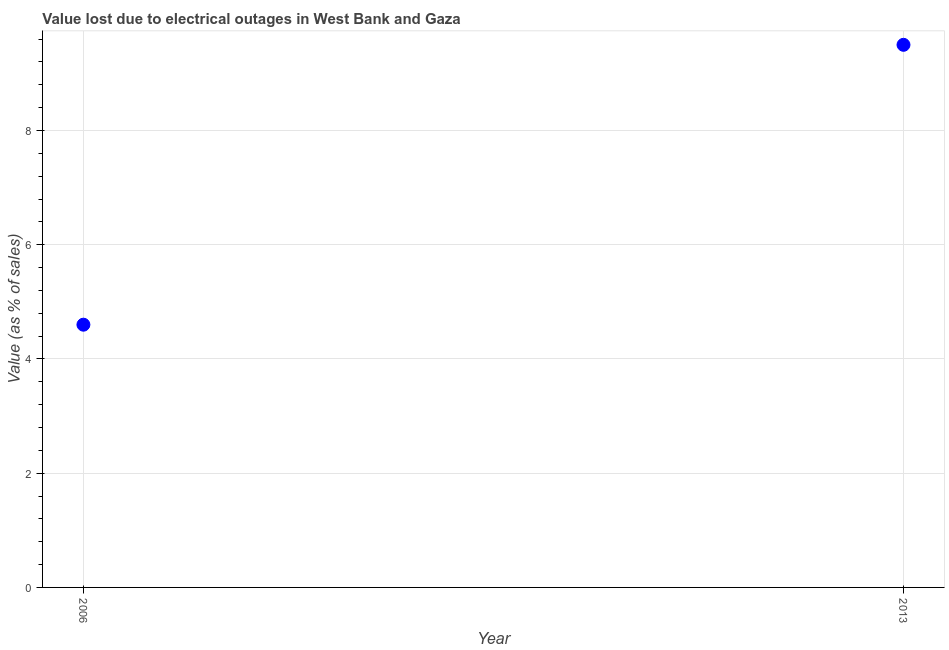What is the value lost due to electrical outages in 2006?
Give a very brief answer. 4.6. Across all years, what is the maximum value lost due to electrical outages?
Keep it short and to the point. 9.5. Across all years, what is the minimum value lost due to electrical outages?
Your answer should be very brief. 4.6. What is the difference between the value lost due to electrical outages in 2006 and 2013?
Offer a very short reply. -4.9. What is the average value lost due to electrical outages per year?
Give a very brief answer. 7.05. What is the median value lost due to electrical outages?
Ensure brevity in your answer.  7.05. Do a majority of the years between 2006 and 2013 (inclusive) have value lost due to electrical outages greater than 7.6 %?
Offer a terse response. No. What is the ratio of the value lost due to electrical outages in 2006 to that in 2013?
Your response must be concise. 0.48. Is the value lost due to electrical outages in 2006 less than that in 2013?
Your answer should be compact. Yes. In how many years, is the value lost due to electrical outages greater than the average value lost due to electrical outages taken over all years?
Provide a short and direct response. 1. Does the value lost due to electrical outages monotonically increase over the years?
Provide a succinct answer. Yes. How many years are there in the graph?
Make the answer very short. 2. Are the values on the major ticks of Y-axis written in scientific E-notation?
Provide a succinct answer. No. Does the graph contain any zero values?
Provide a succinct answer. No. Does the graph contain grids?
Your answer should be very brief. Yes. What is the title of the graph?
Offer a very short reply. Value lost due to electrical outages in West Bank and Gaza. What is the label or title of the X-axis?
Offer a terse response. Year. What is the label or title of the Y-axis?
Provide a short and direct response. Value (as % of sales). What is the ratio of the Value (as % of sales) in 2006 to that in 2013?
Ensure brevity in your answer.  0.48. 